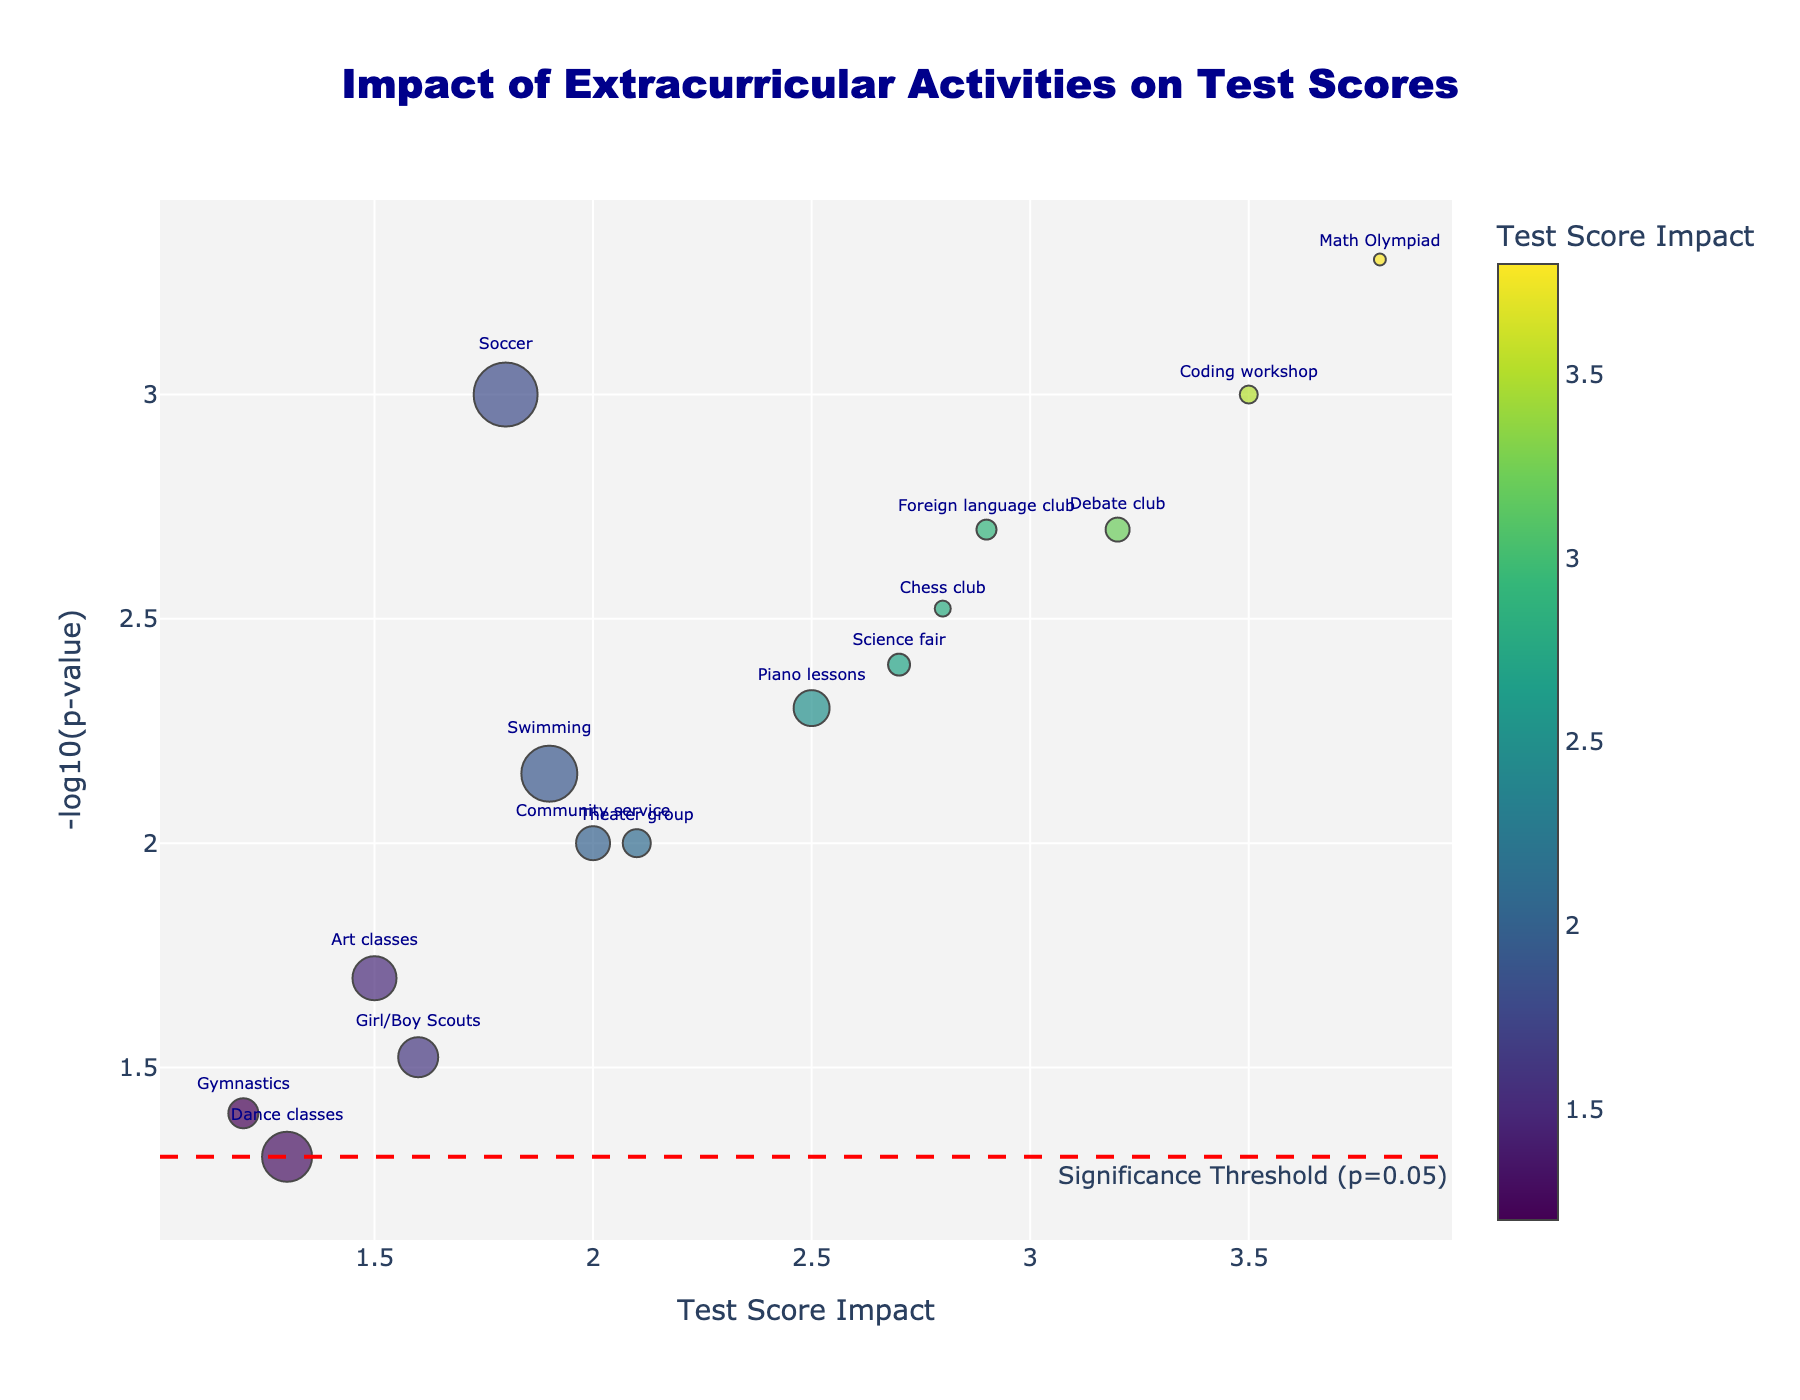1. What is the title of the plot? The title of the plot is prominently positioned at the top and reads 'Impact of Extracurricular Activities on Test Scores'.
Answer: Impact of Extracurricular Activities on Test Scores 2. How many extracurricular activities are plotted? There are markers representing each extracurricular activity on the plot. Counting these, there are 15 activities in total.
Answer: 15 3. What is indicated by the color intensity of the markers? The color intensity of the markers indicates the Test Score Impact, with a color scale shown on the side of the plot. Darker colors typically represent higher values.
Answer: Test Score Impact 4. Which activity has the highest test score impact according to the plot? By looking at the x-axis representing Test Score Impact, Math Olympiad seems to have the highest value.
Answer: Math Olympiad 5. Which extracurricular activity has the smallest participation rate? Using the size of the markers correlating with participation rate, Math Olympiad has the smallest marker and thus the smallest participation rate.
Answer: Math Olympiad 6. What does the dashed red line represent in the plot? The dashed red line represents the significance threshold at p=0.05, as indicated by the annotation next to the line.
Answer: Significance threshold (p=0.05) 7. Compare the test score impact of Gymnastics and Art classes, and which one is higher? Gymnastics has a test score impact of 1.2, and Art classes have an impact of 1.5. Art classes have a higher impact.
Answer: Art classes 8. Which activity has the highest negative log of the p-value (-log10(p)) and what is this value? By examining the y-axis, Math Olympiad is at the highest point, indicating it has the highest -log10(p) value. The exact value is the highest on the plot.
Answer: Math Olympiad, highest value 9. Which activities fall below the significance threshold line? Activities with a -log10(p) value below the red dashed line are below the significance threshold. Dance classes and Gymnastics fall below the line.
Answer: Dance classes, Gymnastics 10. For activities with a test score impact greater than 2.0, what is the range of their participation rates? Activities with a test score impact greater than 2.0 are Piano lessons, Debate club, Chess club, Coding workshop, Math Olympiad, Science fair, and Foreign language club. Their participation rates range from 0.06 to 0.18.
Answer: 0.06 to 0.18 